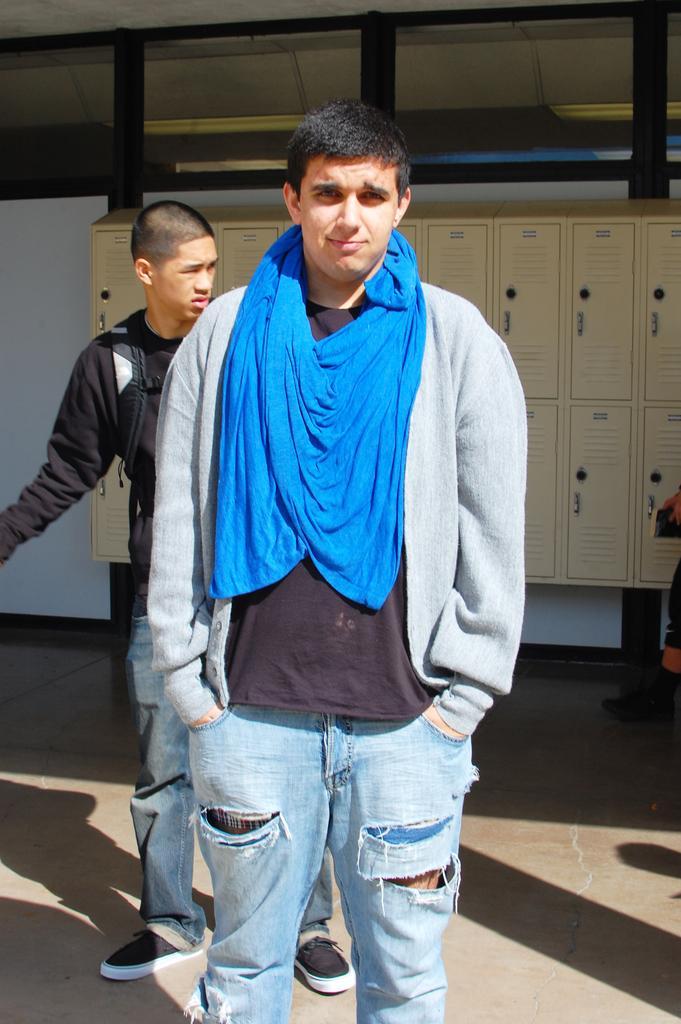Please provide a concise description of this image. In this image in the center there are two people standing and in the background there are some lockers boards glass doors and at the bottom there is walkway and on the right side there are some people. 